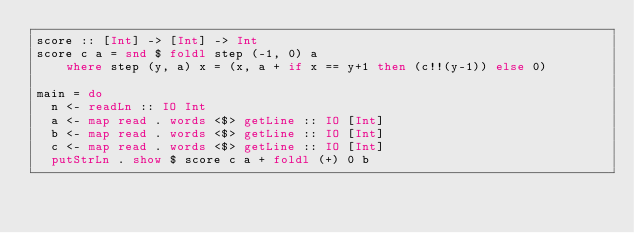<code> <loc_0><loc_0><loc_500><loc_500><_Haskell_>score :: [Int] -> [Int] -> Int
score c a = snd $ foldl step (-1, 0) a
    where step (y, a) x = (x, a + if x == y+1 then (c!!(y-1)) else 0)

main = do
  n <- readLn :: IO Int
  a <- map read . words <$> getLine :: IO [Int]
  b <- map read . words <$> getLine :: IO [Int]
  c <- map read . words <$> getLine :: IO [Int]
  putStrLn . show $ score c a + foldl (+) 0 b
</code> 